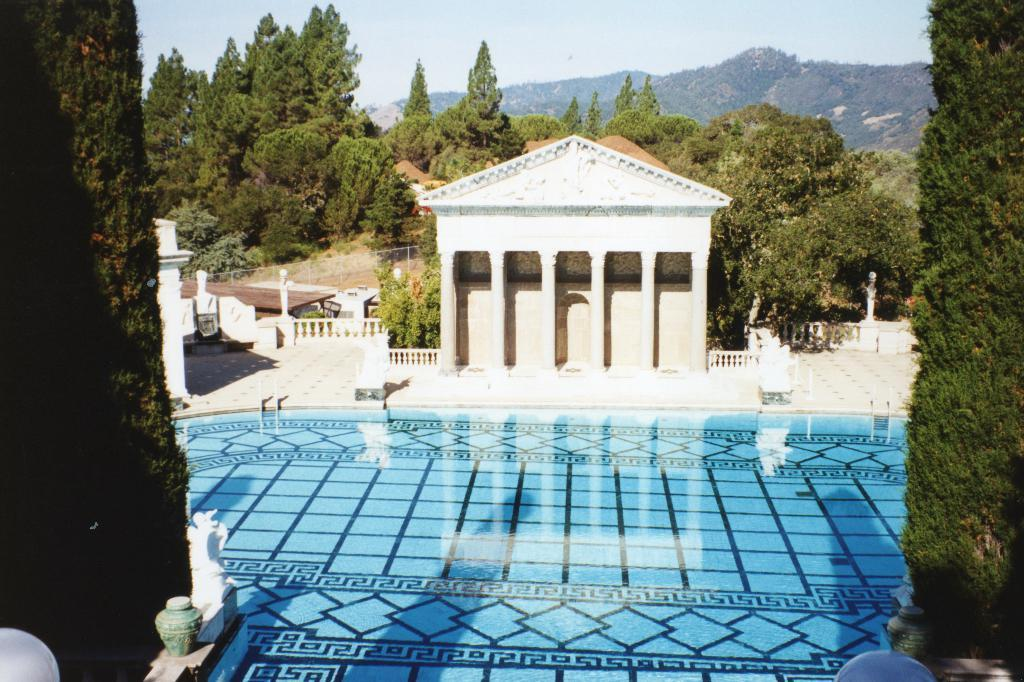What is the main feature in the image? There is a swimming pool in the image. What can be seen on either side of the swimming pool? There are trees to the left and right of the swimming pool. What is visible in the background of the image? There are mountains visible in the background of the image. What structure is present in the front of the image? There is a small roof with pillars in the front of the image. What type of breakfast is being served under the small roof in the image? There is no breakfast or any indication of food being served in the image. 